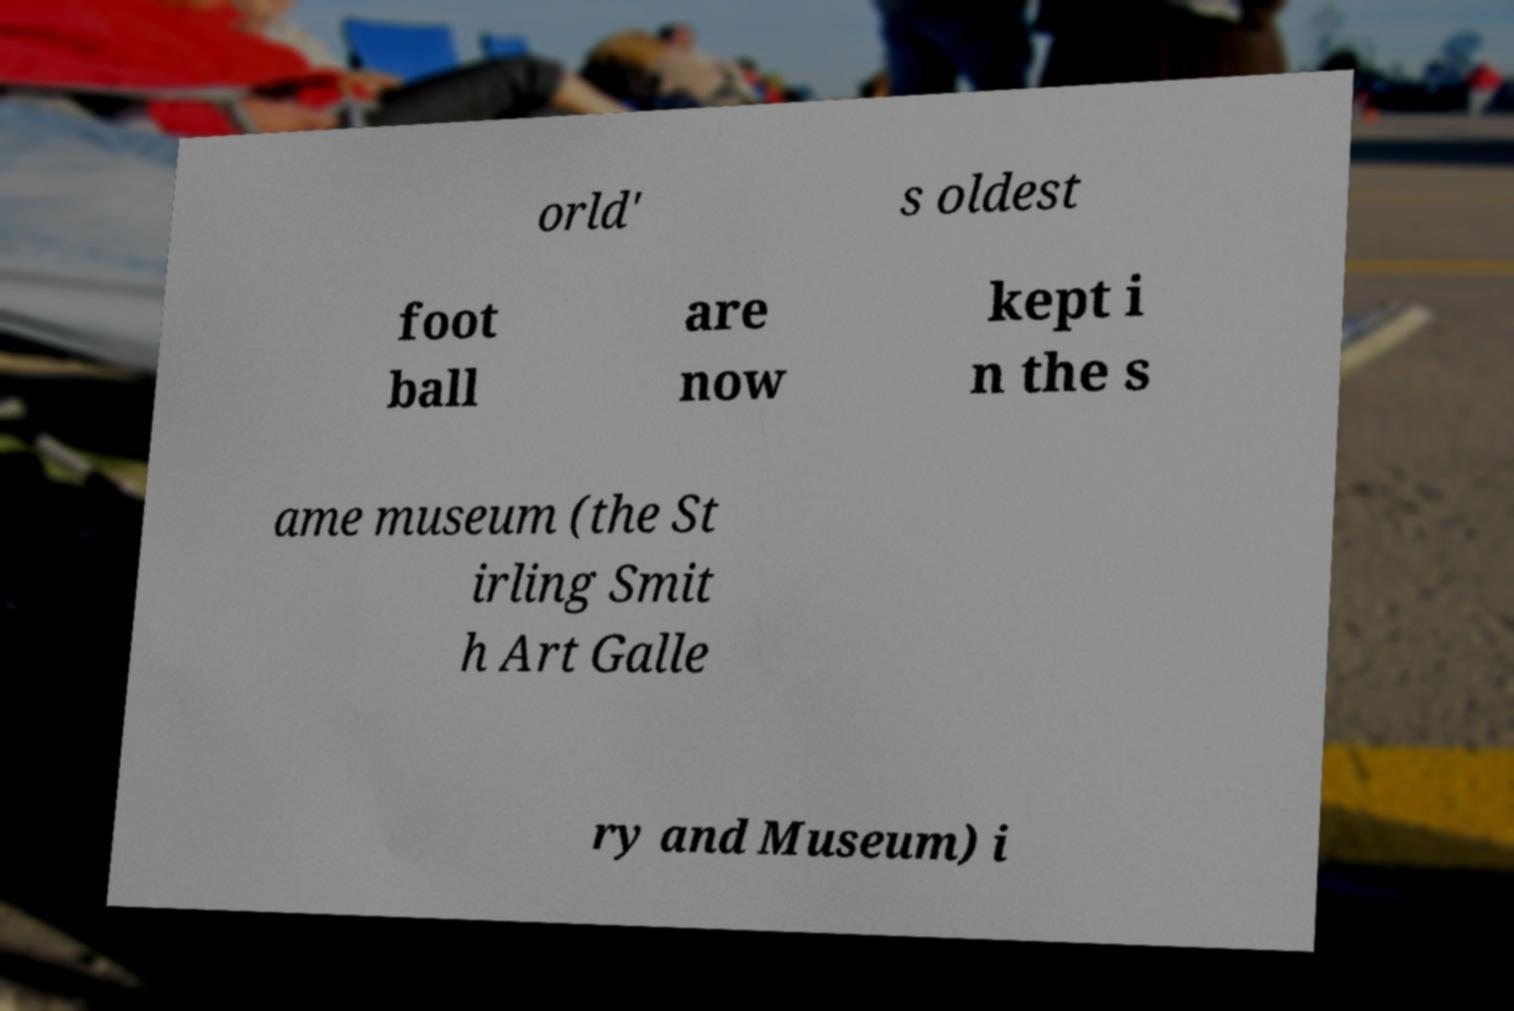What messages or text are displayed in this image? I need them in a readable, typed format. orld' s oldest foot ball are now kept i n the s ame museum (the St irling Smit h Art Galle ry and Museum) i 